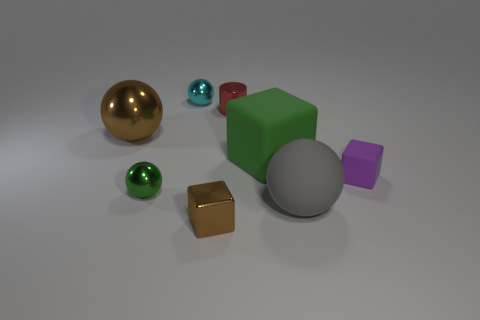Add 1 blue cubes. How many objects exist? 9 Subtract all cubes. How many objects are left? 5 Add 8 tiny purple rubber objects. How many tiny purple rubber objects are left? 9 Add 6 large yellow blocks. How many large yellow blocks exist? 6 Subtract 0 blue balls. How many objects are left? 8 Subtract all cyan metallic balls. Subtract all red cylinders. How many objects are left? 6 